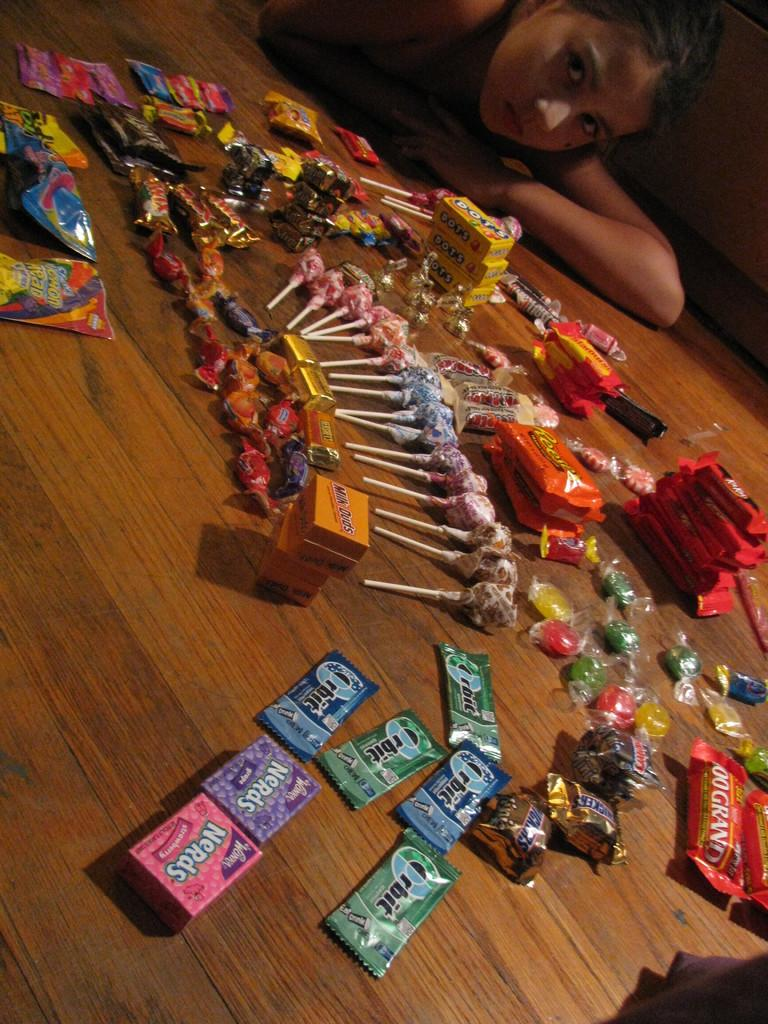What is the main subject of the image? The main subject of the image is a collection of chocolates. What is the surface made of that the chocolates are placed on? The chocolates are on a wooden surface. Are there any people visible in the image? Yes, there is a kid in the image. Where is the kid located in the image? The kid is at the top of the image. What type of jewel is the kid holding in the image? There is no jewel present in the image; the main subject is a collection of chocolates. How many spiders can be seen crawling on the wooden surface in the image? There are no spiders visible in the image; the focus is on the chocolates and the kid. 